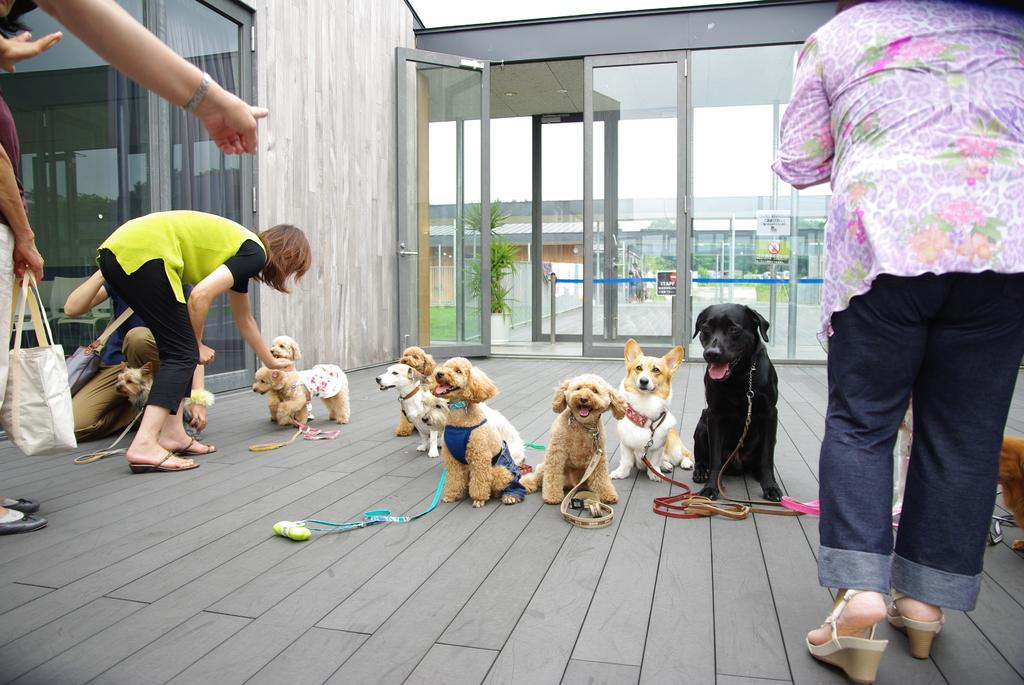How many dogs are present in the image? There are multiple dogs in the image. What are the people in the image doing? There are people standing in the image. Can you describe what one person is holding? One person is holding a bag. What type of door is visible in the image? There is a glass door in the image. What can be seen through the glass door? Buildings and plants are visible through the glass door. Where is the yam stored in the image? There is no yam present in the image. Can you describe the bee's activity in the image? There are no bees present in the image. 